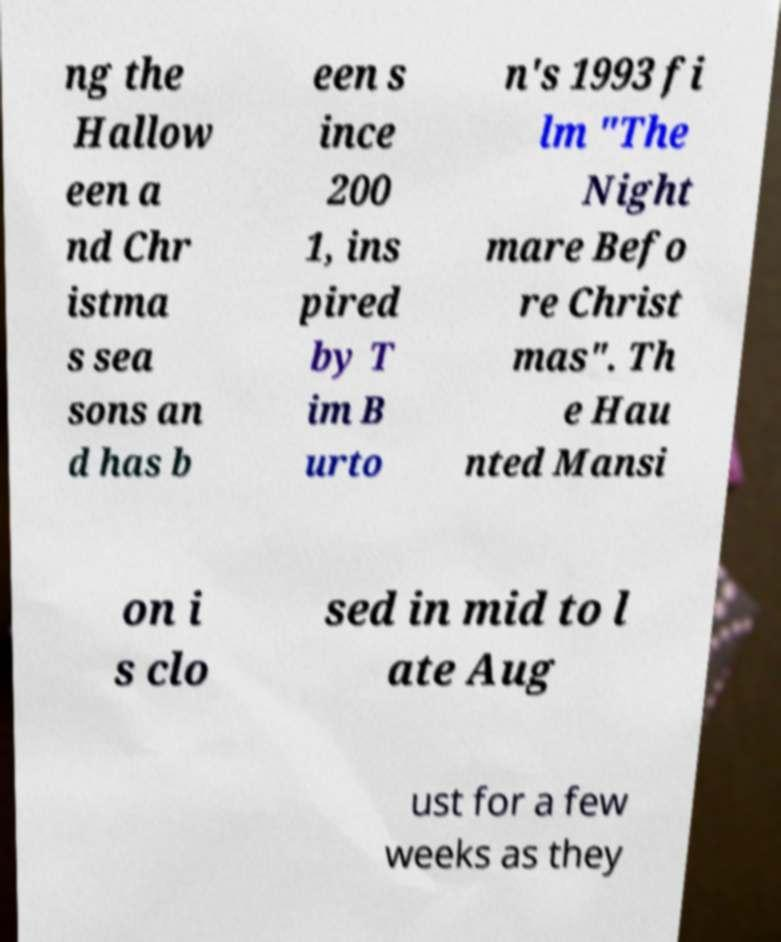Could you extract and type out the text from this image? ng the Hallow een a nd Chr istma s sea sons an d has b een s ince 200 1, ins pired by T im B urto n's 1993 fi lm "The Night mare Befo re Christ mas". Th e Hau nted Mansi on i s clo sed in mid to l ate Aug ust for a few weeks as they 